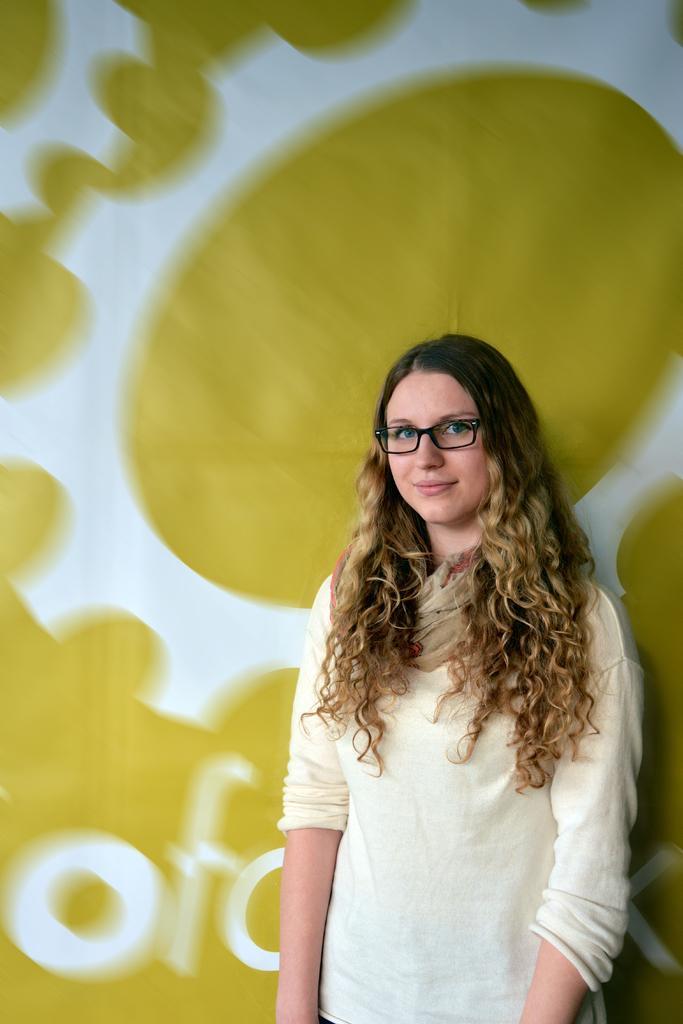Please provide a concise description of this image. This image is taken indoors. In the background there is a poster with a text and an image on it. In the middle of the image a girl is standing and she is with a smiling face. 